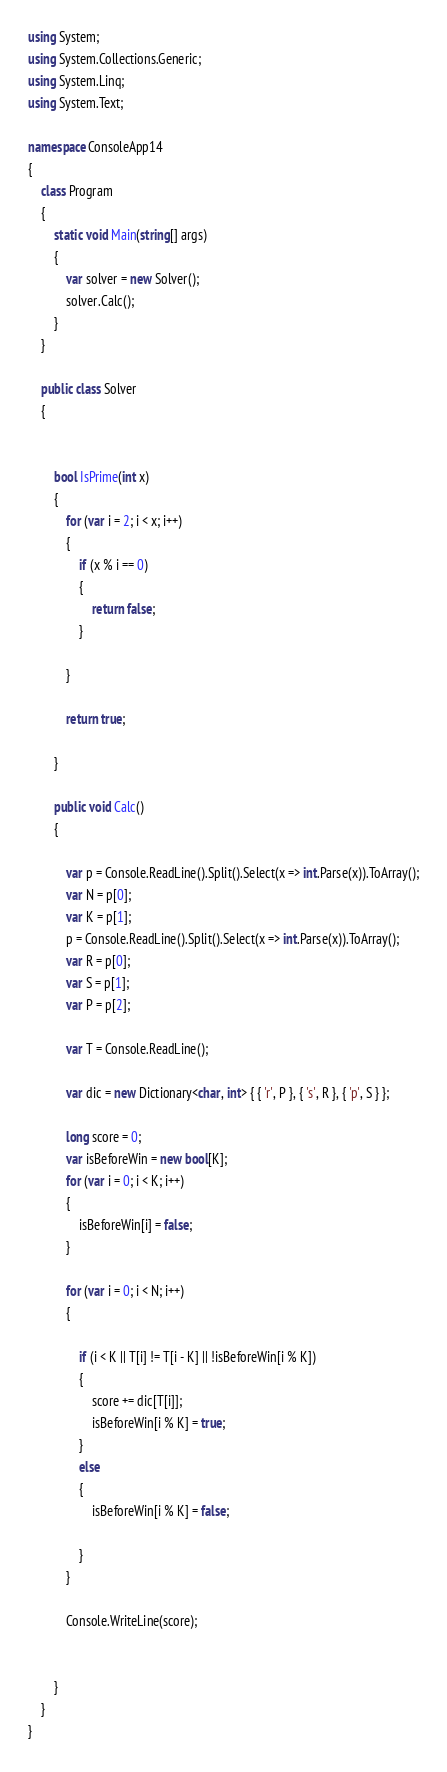<code> <loc_0><loc_0><loc_500><loc_500><_C#_>using System;
using System.Collections.Generic;
using System.Linq;
using System.Text;

namespace ConsoleApp14
{
    class Program
    {
        static void Main(string[] args)
        {
            var solver = new Solver();
            solver.Calc();
        }
    }

    public class Solver
    {


        bool IsPrime(int x)
        {
            for (var i = 2; i < x; i++)
            {
                if (x % i == 0)
                {
                    return false;
                }

            }

            return true;

        }

        public void Calc()
        {

            var p = Console.ReadLine().Split().Select(x => int.Parse(x)).ToArray();
            var N = p[0];
            var K = p[1];
            p = Console.ReadLine().Split().Select(x => int.Parse(x)).ToArray();
            var R = p[0];
            var S = p[1];
            var P = p[2];

            var T = Console.ReadLine();

            var dic = new Dictionary<char, int> { { 'r', P }, { 's', R }, { 'p', S } };

            long score = 0;
            var isBeforeWin = new bool[K];
            for (var i = 0; i < K; i++)
            {
                isBeforeWin[i] = false;
            }

            for (var i = 0; i < N; i++)
            {

                if (i < K || T[i] != T[i - K] || !isBeforeWin[i % K])
                {
                    score += dic[T[i]];
                    isBeforeWin[i % K] = true;
                }
                else
                {
                    isBeforeWin[i % K] = false;

                }
            }

            Console.WriteLine(score);


        }
    }
}</code> 